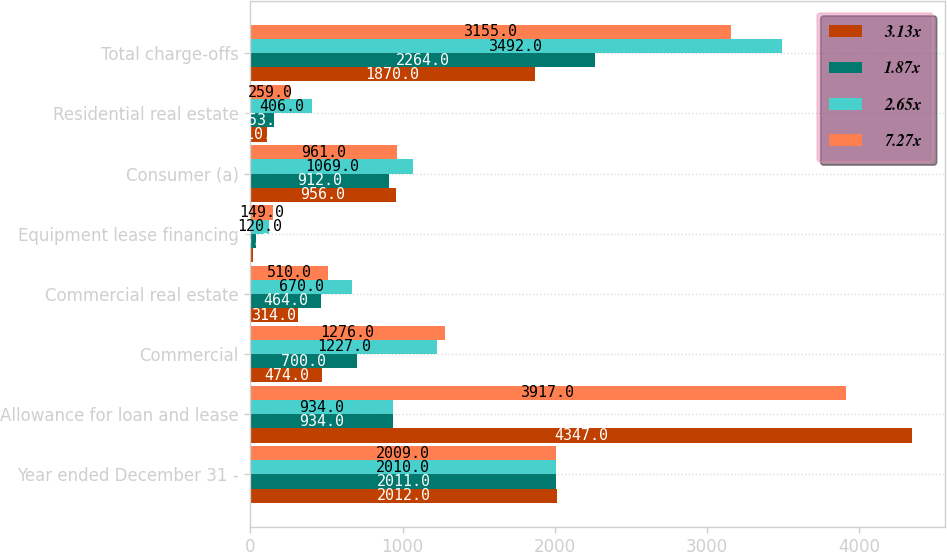Convert chart to OTSL. <chart><loc_0><loc_0><loc_500><loc_500><stacked_bar_chart><ecel><fcel>Year ended December 31 -<fcel>Allowance for loan and lease<fcel>Commercial<fcel>Commercial real estate<fcel>Equipment lease financing<fcel>Consumer (a)<fcel>Residential real estate<fcel>Total charge-offs<nl><fcel>3.13x<fcel>2012<fcel>4347<fcel>474<fcel>314<fcel>16<fcel>956<fcel>110<fcel>1870<nl><fcel>1.87x<fcel>2011<fcel>934<fcel>700<fcel>464<fcel>35<fcel>912<fcel>153<fcel>2264<nl><fcel>2.65x<fcel>2010<fcel>934<fcel>1227<fcel>670<fcel>120<fcel>1069<fcel>406<fcel>3492<nl><fcel>7.27x<fcel>2009<fcel>3917<fcel>1276<fcel>510<fcel>149<fcel>961<fcel>259<fcel>3155<nl></chart> 